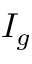Convert formula to latex. <formula><loc_0><loc_0><loc_500><loc_500>I _ { g }</formula> 